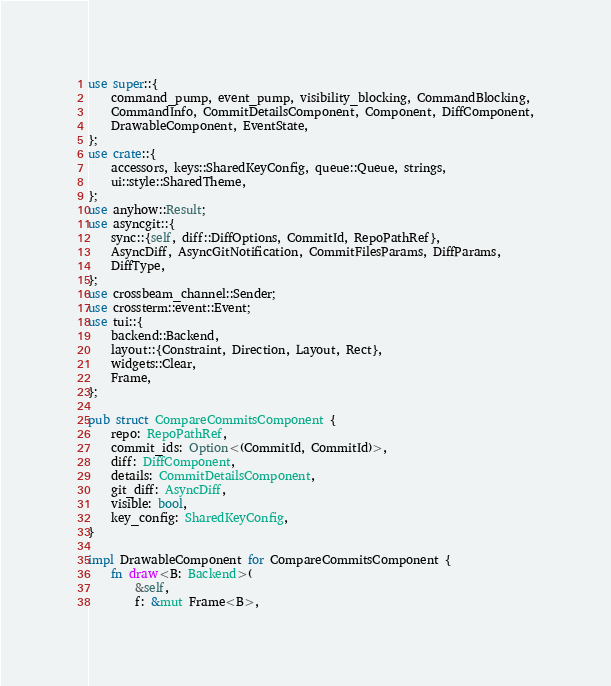Convert code to text. <code><loc_0><loc_0><loc_500><loc_500><_Rust_>use super::{
	command_pump, event_pump, visibility_blocking, CommandBlocking,
	CommandInfo, CommitDetailsComponent, Component, DiffComponent,
	DrawableComponent, EventState,
};
use crate::{
	accessors, keys::SharedKeyConfig, queue::Queue, strings,
	ui::style::SharedTheme,
};
use anyhow::Result;
use asyncgit::{
	sync::{self, diff::DiffOptions, CommitId, RepoPathRef},
	AsyncDiff, AsyncGitNotification, CommitFilesParams, DiffParams,
	DiffType,
};
use crossbeam_channel::Sender;
use crossterm::event::Event;
use tui::{
	backend::Backend,
	layout::{Constraint, Direction, Layout, Rect},
	widgets::Clear,
	Frame,
};

pub struct CompareCommitsComponent {
	repo: RepoPathRef,
	commit_ids: Option<(CommitId, CommitId)>,
	diff: DiffComponent,
	details: CommitDetailsComponent,
	git_diff: AsyncDiff,
	visible: bool,
	key_config: SharedKeyConfig,
}

impl DrawableComponent for CompareCommitsComponent {
	fn draw<B: Backend>(
		&self,
		f: &mut Frame<B>,</code> 